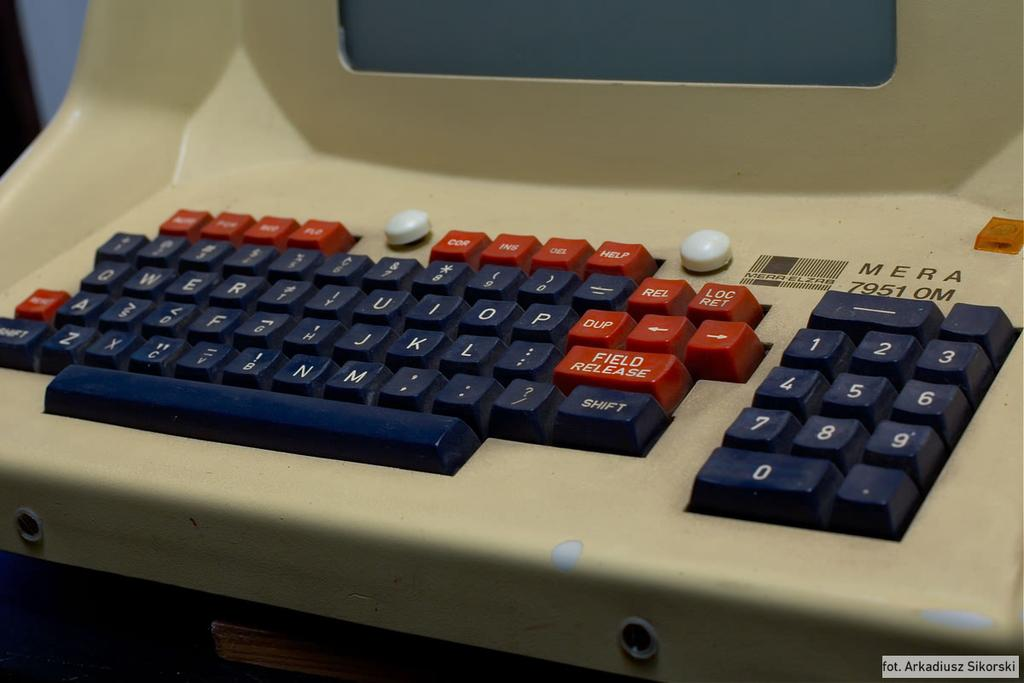Provide a one-sentence caption for the provided image. mera 7951 om beige computer terminal with black and red keys. 